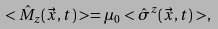<formula> <loc_0><loc_0><loc_500><loc_500>< \hat { M } _ { z } ( \vec { x } , t ) > = \mu _ { 0 } < \hat { \sigma } ^ { z } ( \vec { x } , t ) > ,</formula> 